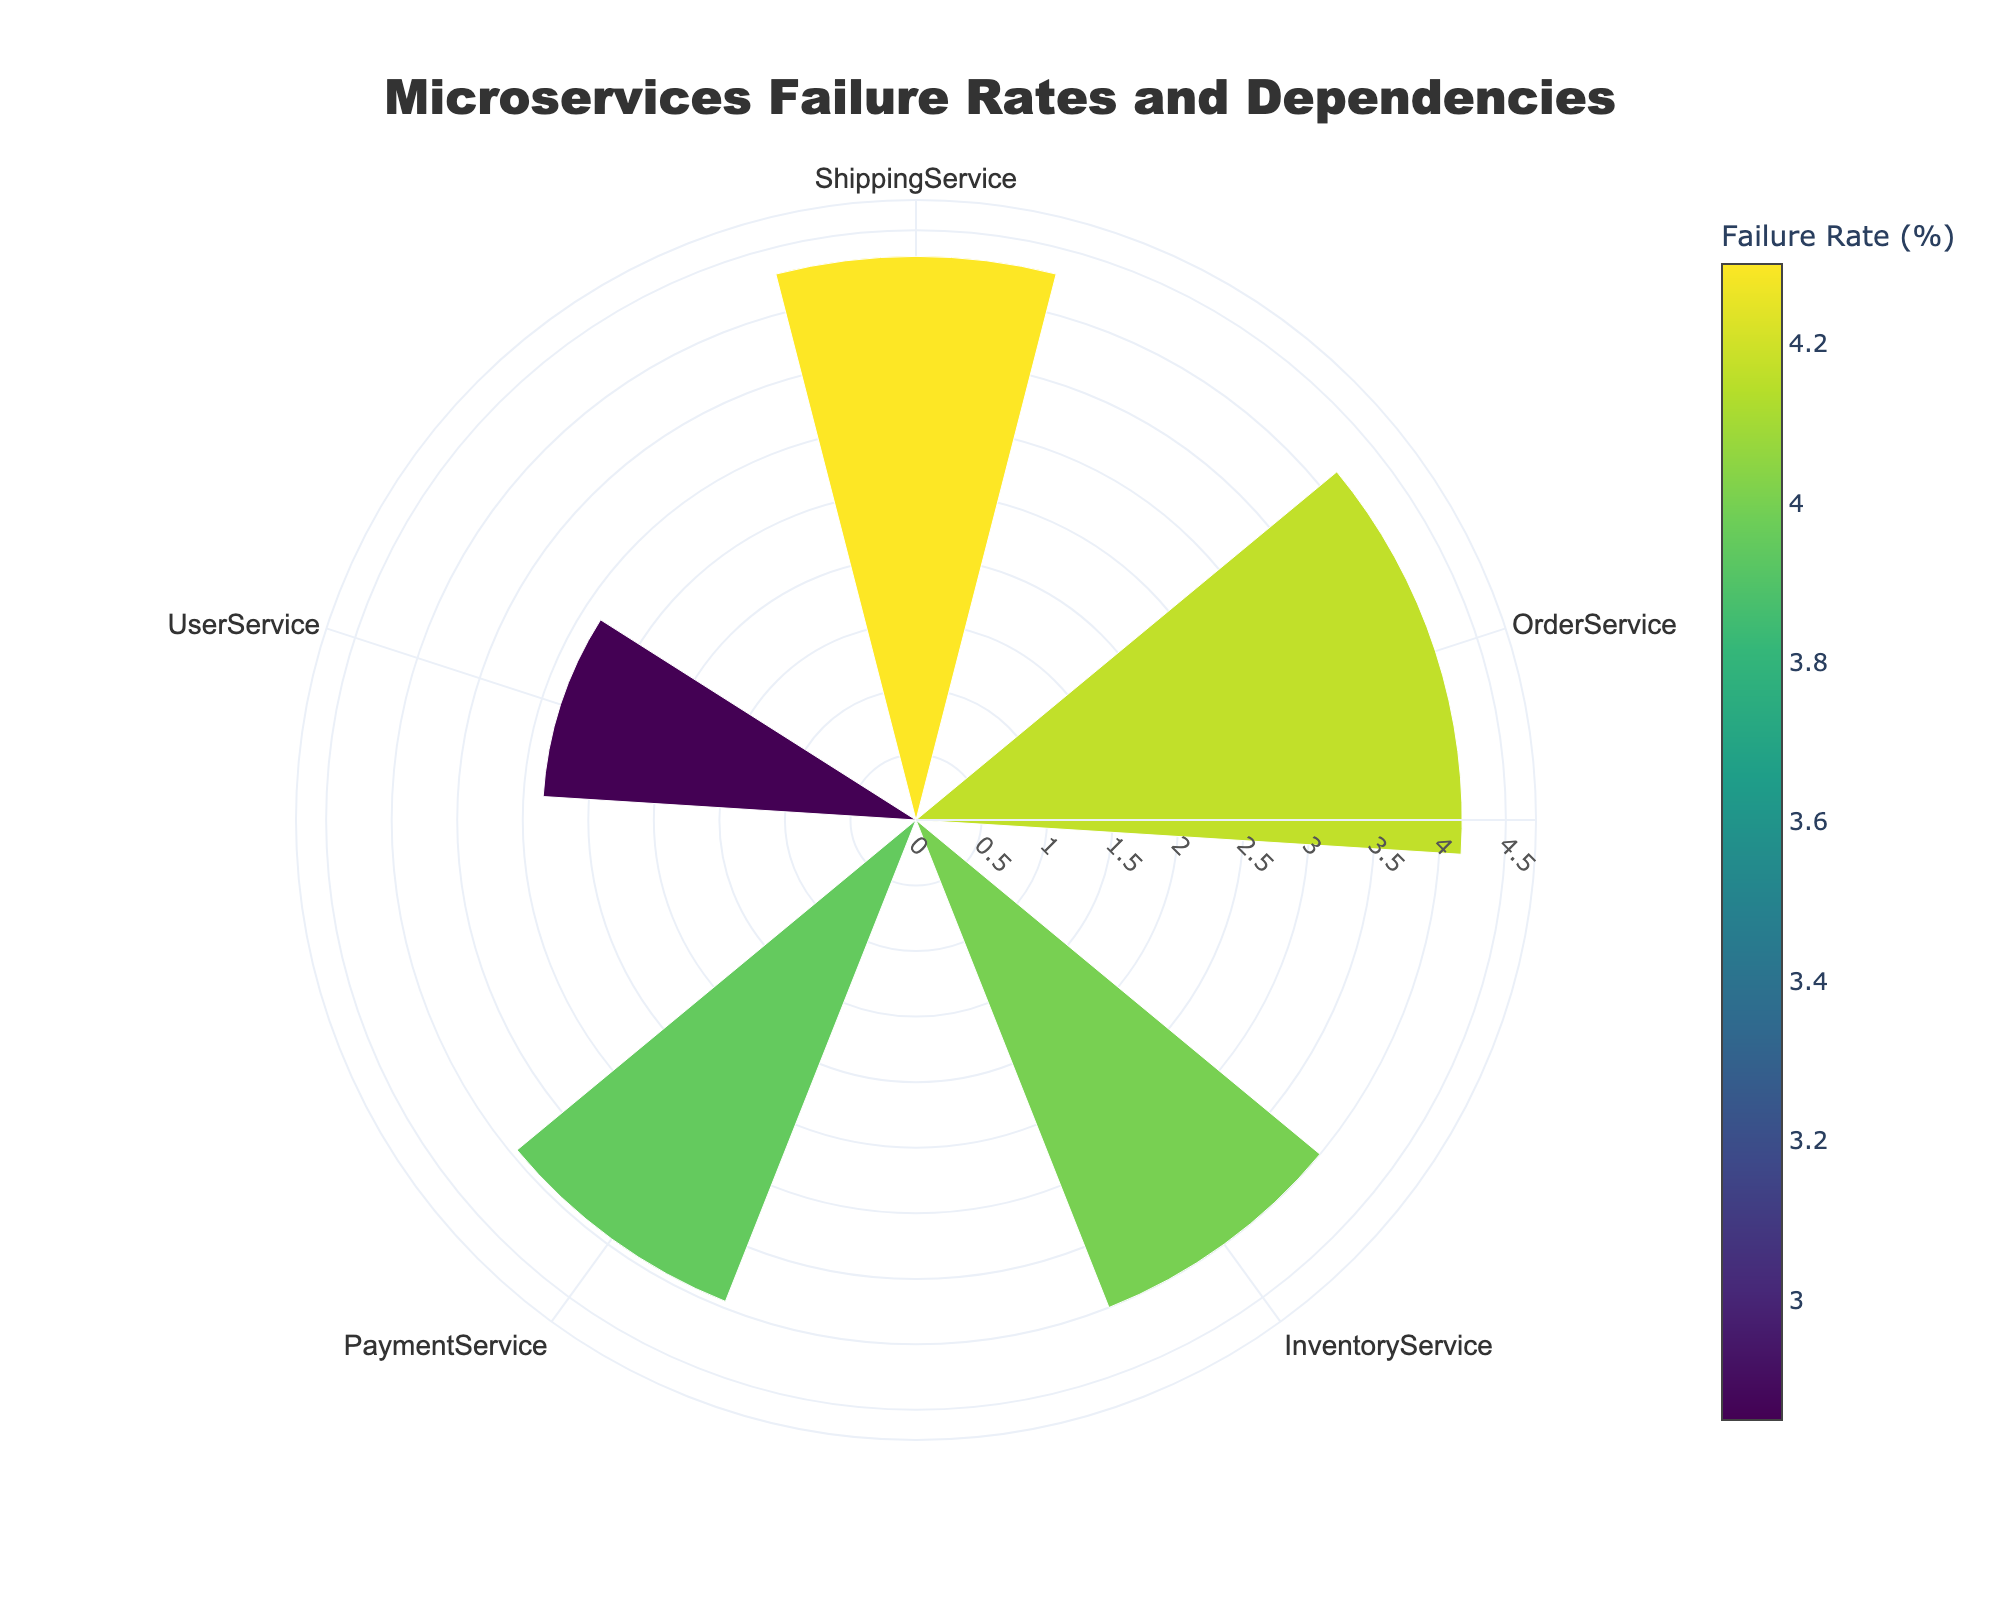How many microservices are shown in the plot? To determine the number of microservices, simply count the distinct elements plotted around the polar chart.
Answer: 5 What is the highest failure rate percentage among the microservices? Locate the highest bar on the plot, which indicates the highest value on the radial axis. Note the corresponding percentage.
Answer: 5.5% Which microservice has the lowest average failure rate? Find the smallest bar on the chart and read off the corresponding microservice name at the position it occupies around the polar axis.
Answer: UserService How many dependencies does ShippingService have? Look at the width of the bar corresponding to ShippingService. The hovertext or width can be cross-referenced to find the number of dependencies.
Answer: 2 What is the average failure rate of InventoryService? Identify the bar corresponding to InventoryService and note the failure rate shown at that angle. The hovertext will also provide this data.
Answer: 4.0% Compare the failure rates of PaymentService and OrderService. Which one is higher? Locate the bars representing both PaymentService and OrderService, then compare their lengths (or the failure rates shown in their hovertext).
Answer: OrderService Rank the microservices in terms of their average failure rates from highest to lowest. Examine the lengths of bars or hovertexts for each microservice, then order them from the largest value to the smallest value.
Answer: OrderService, ShippingService, InventoryService, PaymentService, UserService What is the total number of dependencies for all microservices combined? Sum the number of dependencies for each microservice by reading their widths or hovertexts, then add them.
Answer: 10 How does OrderService's failure rate compare to the average failure rate of all microservices? Calculate the average failure rate by summing the failure rates of all microservices and dividing by the number of microservices. Then, compare this value to OrderService's failure rate.
Answer: Above Average 